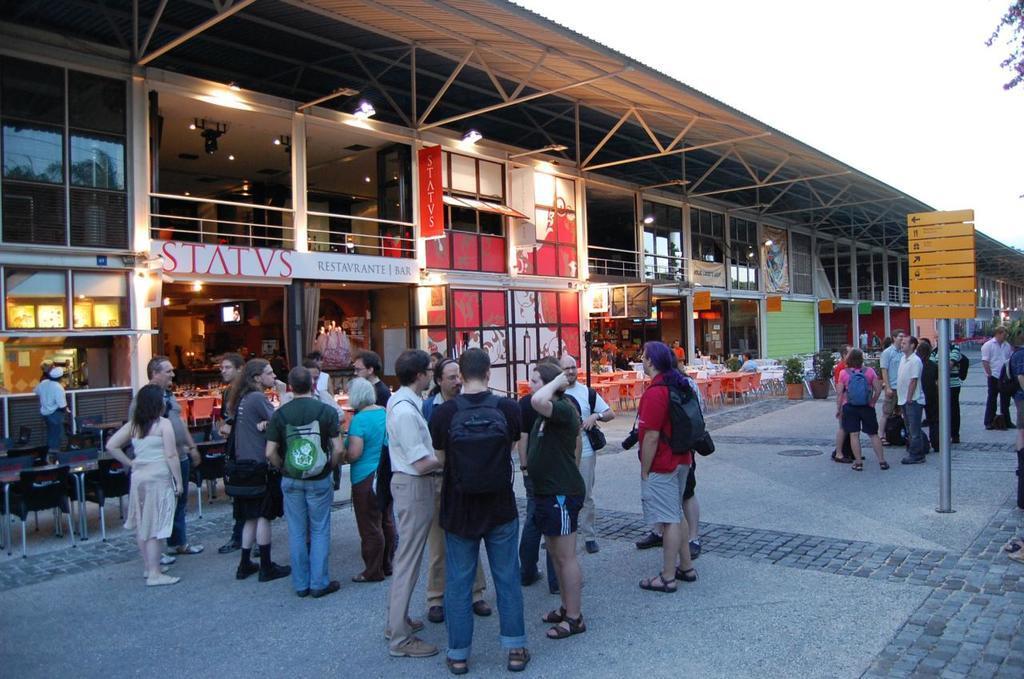How would you summarize this image in a sentence or two? In this image I can see a group of people standing and few people are holding bag. Back Side I can see chairs,tables and buildings. In front I can see a yellow color signboard and lights. We can see few stores and flower pots. The sky is in white color. 